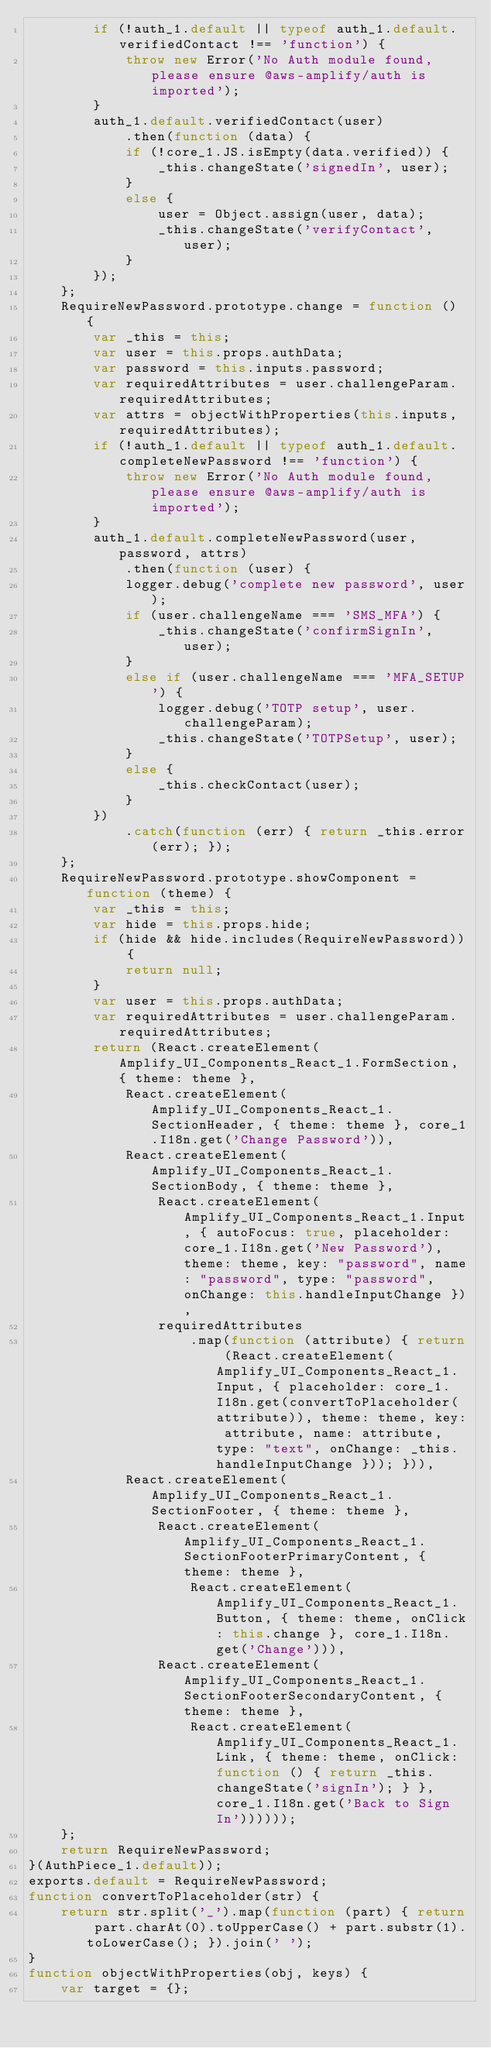Convert code to text. <code><loc_0><loc_0><loc_500><loc_500><_JavaScript_>        if (!auth_1.default || typeof auth_1.default.verifiedContact !== 'function') {
            throw new Error('No Auth module found, please ensure @aws-amplify/auth is imported');
        }
        auth_1.default.verifiedContact(user)
            .then(function (data) {
            if (!core_1.JS.isEmpty(data.verified)) {
                _this.changeState('signedIn', user);
            }
            else {
                user = Object.assign(user, data);
                _this.changeState('verifyContact', user);
            }
        });
    };
    RequireNewPassword.prototype.change = function () {
        var _this = this;
        var user = this.props.authData;
        var password = this.inputs.password;
        var requiredAttributes = user.challengeParam.requiredAttributes;
        var attrs = objectWithProperties(this.inputs, requiredAttributes);
        if (!auth_1.default || typeof auth_1.default.completeNewPassword !== 'function') {
            throw new Error('No Auth module found, please ensure @aws-amplify/auth is imported');
        }
        auth_1.default.completeNewPassword(user, password, attrs)
            .then(function (user) {
            logger.debug('complete new password', user);
            if (user.challengeName === 'SMS_MFA') {
                _this.changeState('confirmSignIn', user);
            }
            else if (user.challengeName === 'MFA_SETUP') {
                logger.debug('TOTP setup', user.challengeParam);
                _this.changeState('TOTPSetup', user);
            }
            else {
                _this.checkContact(user);
            }
        })
            .catch(function (err) { return _this.error(err); });
    };
    RequireNewPassword.prototype.showComponent = function (theme) {
        var _this = this;
        var hide = this.props.hide;
        if (hide && hide.includes(RequireNewPassword)) {
            return null;
        }
        var user = this.props.authData;
        var requiredAttributes = user.challengeParam.requiredAttributes;
        return (React.createElement(Amplify_UI_Components_React_1.FormSection, { theme: theme },
            React.createElement(Amplify_UI_Components_React_1.SectionHeader, { theme: theme }, core_1.I18n.get('Change Password')),
            React.createElement(Amplify_UI_Components_React_1.SectionBody, { theme: theme },
                React.createElement(Amplify_UI_Components_React_1.Input, { autoFocus: true, placeholder: core_1.I18n.get('New Password'), theme: theme, key: "password", name: "password", type: "password", onChange: this.handleInputChange }),
                requiredAttributes
                    .map(function (attribute) { return (React.createElement(Amplify_UI_Components_React_1.Input, { placeholder: core_1.I18n.get(convertToPlaceholder(attribute)), theme: theme, key: attribute, name: attribute, type: "text", onChange: _this.handleInputChange })); })),
            React.createElement(Amplify_UI_Components_React_1.SectionFooter, { theme: theme },
                React.createElement(Amplify_UI_Components_React_1.SectionFooterPrimaryContent, { theme: theme },
                    React.createElement(Amplify_UI_Components_React_1.Button, { theme: theme, onClick: this.change }, core_1.I18n.get('Change'))),
                React.createElement(Amplify_UI_Components_React_1.SectionFooterSecondaryContent, { theme: theme },
                    React.createElement(Amplify_UI_Components_React_1.Link, { theme: theme, onClick: function () { return _this.changeState('signIn'); } }, core_1.I18n.get('Back to Sign In'))))));
    };
    return RequireNewPassword;
}(AuthPiece_1.default));
exports.default = RequireNewPassword;
function convertToPlaceholder(str) {
    return str.split('_').map(function (part) { return part.charAt(0).toUpperCase() + part.substr(1).toLowerCase(); }).join(' ');
}
function objectWithProperties(obj, keys) {
    var target = {};</code> 